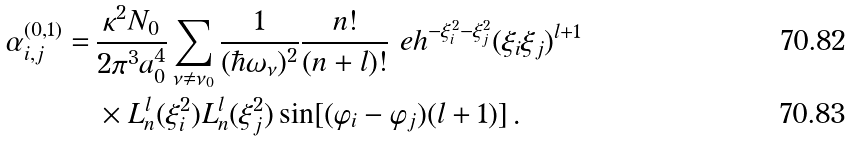<formula> <loc_0><loc_0><loc_500><loc_500>\alpha _ { i , j } ^ { ( 0 , 1 ) } = \, & \frac { \kappa ^ { 2 } N _ { 0 } } { 2 \pi ^ { 3 } a _ { 0 } ^ { 4 } } \sum _ { \nu \neq \nu _ { 0 } } \frac { 1 } { ( \hbar { \omega } _ { \nu } ) ^ { 2 } } \frac { n ! } { ( n + l ) ! } \ e h ^ { - \xi _ { i } ^ { 2 } - \xi _ { j } ^ { 2 } } ( \xi _ { i } \xi _ { j } ) ^ { l + 1 } \\ & \times L _ { n } ^ { l } ( \xi _ { i } ^ { 2 } ) L _ { n } ^ { l } ( \xi _ { j } ^ { 2 } ) \sin [ ( \varphi _ { i } - \varphi _ { j } ) ( l + 1 ) ] \, .</formula> 